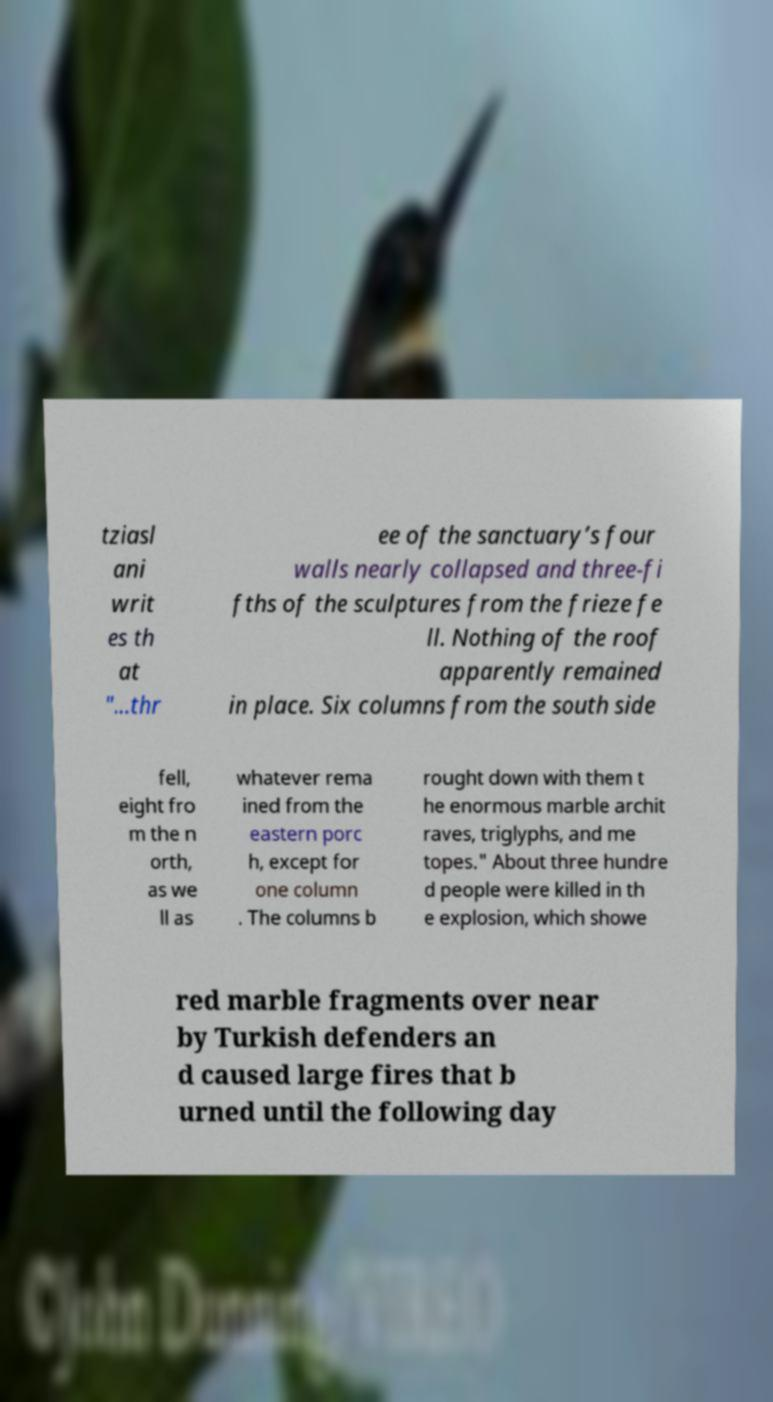What messages or text are displayed in this image? I need them in a readable, typed format. tziasl ani writ es th at "...thr ee of the sanctuary’s four walls nearly collapsed and three-fi fths of the sculptures from the frieze fe ll. Nothing of the roof apparently remained in place. Six columns from the south side fell, eight fro m the n orth, as we ll as whatever rema ined from the eastern porc h, except for one column . The columns b rought down with them t he enormous marble archit raves, triglyphs, and me topes." About three hundre d people were killed in th e explosion, which showe red marble fragments over near by Turkish defenders an d caused large fires that b urned until the following day 